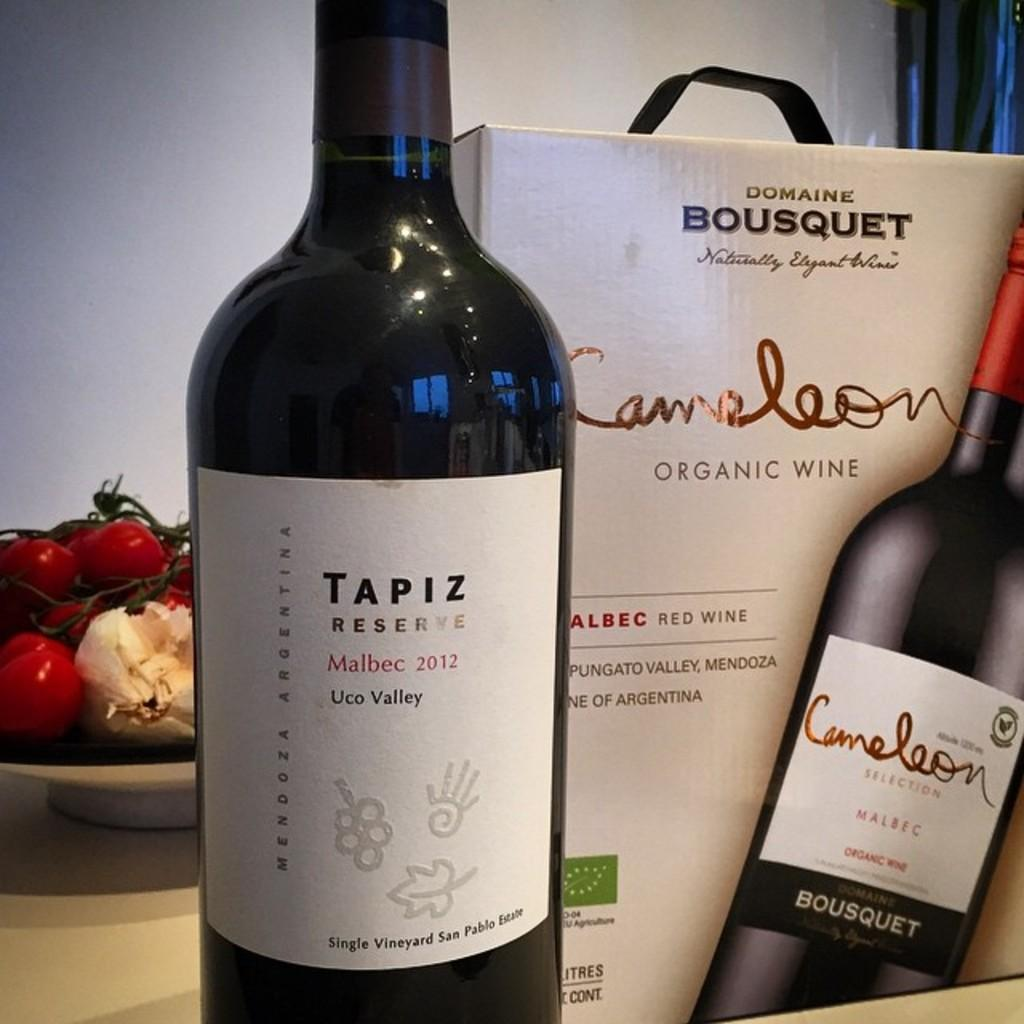What is one of the objects on the table in the image? There is a bottle in the image. What else can be seen on the table? There is a box and a plate with vegetables in the image. What is the purpose of the plate with vegetables? The plate with vegetables is likely for serving or eating. What can be seen in the background of the image? There is a wall visible in the background of the image. Where is the drawer located in the image? There is no drawer present in the image. What type of engine can be seen powering the objects in the image? There is no engine present in the image; the objects are stationary on the table. 